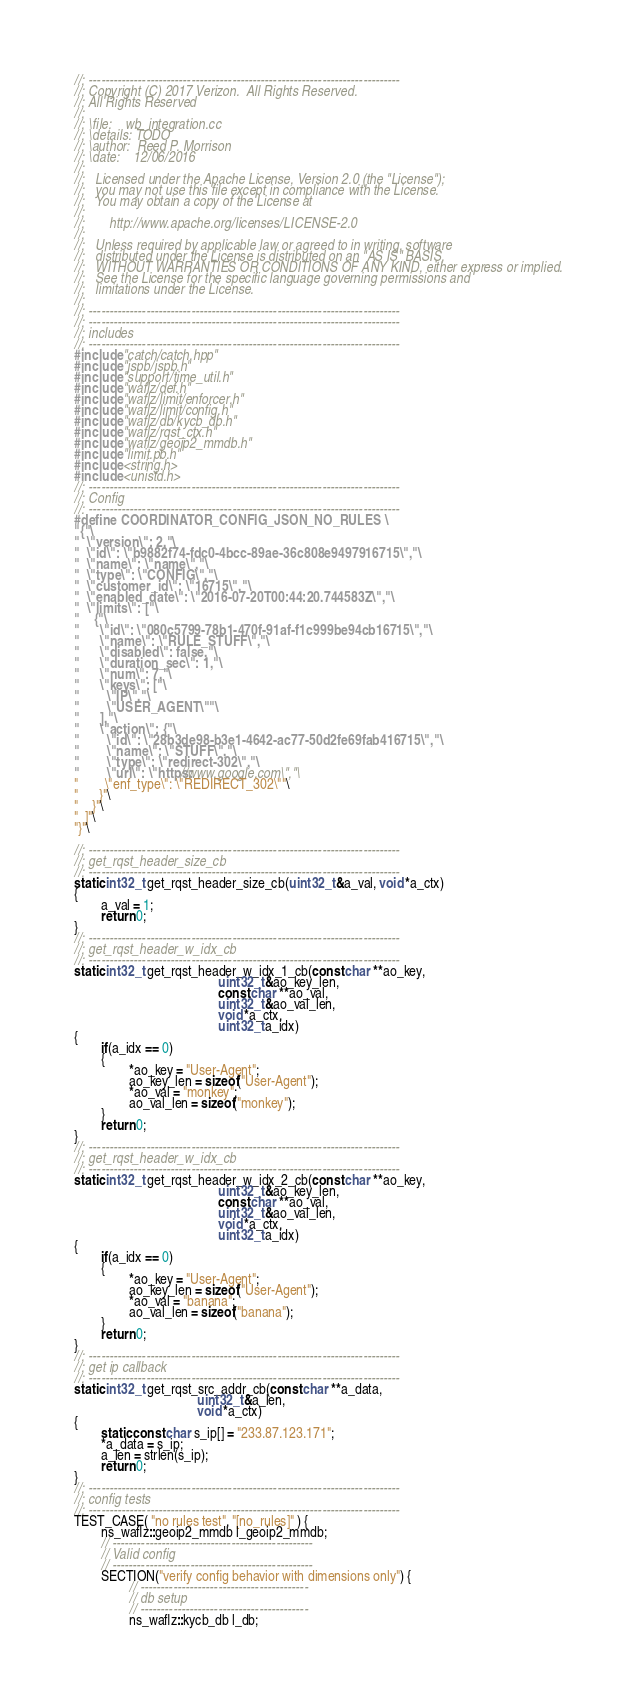<code> <loc_0><loc_0><loc_500><loc_500><_C++_>//: ----------------------------------------------------------------------------
//: Copyright (C) 2017 Verizon.  All Rights Reserved.
//: All Rights Reserved
//:
//: \file:    wb_integration.cc
//: \details: TODO
//: \author:  Reed P. Morrison
//: \date:    12/06/2016
//:
//:   Licensed under the Apache License, Version 2.0 (the "License");
//:   you may not use this file except in compliance with the License.
//:   You may obtain a copy of the License at
//:
//:       http://www.apache.org/licenses/LICENSE-2.0
//:
//:   Unless required by applicable law or agreed to in writing, software
//:   distributed under the License is distributed on an "AS IS" BASIS,
//:   WITHOUT WARRANTIES OR CONDITIONS OF ANY KIND, either express or implied.
//:   See the License for the specific language governing permissions and
//:   limitations under the License.
//:
//: ----------------------------------------------------------------------------
//: ----------------------------------------------------------------------------
//: includes
//: ----------------------------------------------------------------------------
#include "catch/catch.hpp"
#include "jspb/jspb.h"
#include "support/time_util.h"
#include "waflz/def.h"
#include "waflz/limit/enforcer.h"
#include "waflz/limit/config.h"
#include "waflz/db/kycb_db.h"
#include "waflz/rqst_ctx.h"
#include "waflz/geoip2_mmdb.h"
#include "limit.pb.h"
#include <string.h>
#include <unistd.h>
//: ----------------------------------------------------------------------------
//: Config
//: ----------------------------------------------------------------------------
#define COORDINATOR_CONFIG_JSON_NO_RULES \
"{"\
"  \"version\": 2,"\
"  \"id\": \"b9882f74-fdc0-4bcc-89ae-36c808e9497916715\","\
"  \"name\": \"name\","\
"  \"type\": \"CONFIG\","\
"  \"customer_id\": \"16715\","\
"  \"enabled_date\": \"2016-07-20T00:44:20.744583Z\","\
"  \"limits\": ["\
"    {"\
"      \"id\": \"080c5799-78b1-470f-91af-f1c999be94cb16715\","\
"      \"name\": \"RULE_STUFF\","\
"      \"disabled\": false,"\
"      \"duration_sec\": 1,"\
"      \"num\": 7,"\
"      \"keys\": ["\
"        \"IP\","\
"        \"USER_AGENT\""\
"      ],"\
"      \"action\": {"\
"        \"id\": \"28b3de98-b3e1-4642-ac77-50d2fe69fab416715\","\
"        \"name\": \"STUFF\","\
"        \"type\": \"redirect-302\","\
"        \"url\": \"https://www.google.com\","\
"        \"enf_type\": \"REDIRECT_302\""\
"      }"\
"    }"\
"  ]"\
"}"\

//: ----------------------------------------------------------------------------
//: get_rqst_header_size_cb
//: ----------------------------------------------------------------------------
static int32_t get_rqst_header_size_cb(uint32_t &a_val, void *a_ctx)
{
        a_val = 1;
        return 0;
}
//: ----------------------------------------------------------------------------
//: get_rqst_header_w_idx_cb
//: ----------------------------------------------------------------------------
static int32_t get_rqst_header_w_idx_1_cb(const char **ao_key,
                                          uint32_t &ao_key_len,
                                          const char **ao_val,
                                          uint32_t &ao_val_len,
                                          void *a_ctx,
                                          uint32_t a_idx)
{
        if(a_idx == 0)
        {
                *ao_key = "User-Agent";
                ao_key_len = sizeof("User-Agent");
                *ao_val = "monkey";
                ao_val_len = sizeof("monkey");
        }
        return 0;
}
//: ----------------------------------------------------------------------------
//: get_rqst_header_w_idx_cb
//: ----------------------------------------------------------------------------
static int32_t get_rqst_header_w_idx_2_cb(const char **ao_key,
                                          uint32_t &ao_key_len,
                                          const char **ao_val,
                                          uint32_t &ao_val_len,
                                          void *a_ctx,
                                          uint32_t a_idx)
{
        if(a_idx == 0)
        {
                *ao_key = "User-Agent";
                ao_key_len = sizeof("User-Agent");
                *ao_val = "banana";
                ao_val_len = sizeof("banana");
        }
        return 0;
}
//: ----------------------------------------------------------------------------
//: get ip callback
//: ----------------------------------------------------------------------------
static int32_t get_rqst_src_addr_cb(const char **a_data,
                                    uint32_t &a_len,
                                    void *a_ctx)
{
        static const char s_ip[] = "233.87.123.171";
        *a_data = s_ip;
        a_len = strlen(s_ip);
        return 0;
}
//: ----------------------------------------------------------------------------
//: config tests
//: ----------------------------------------------------------------------------
TEST_CASE( "no rules test", "[no_rules]" ) {
        ns_waflz::geoip2_mmdb l_geoip2_mmdb;
        // -------------------------------------------------
        // Valid config
        // -------------------------------------------------
        SECTION("verify config behavior with dimensions only") {
                // -----------------------------------------
                // db setup
                // -----------------------------------------
                ns_waflz::kycb_db l_db;</code> 